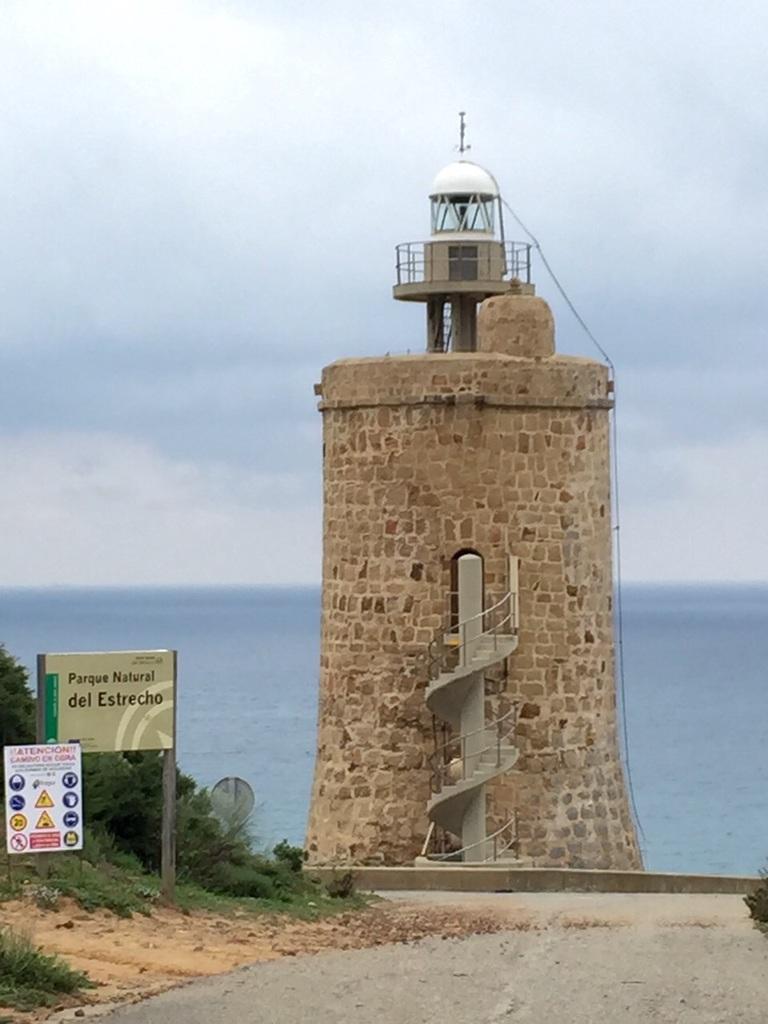Could you give a brief overview of what you see in this image? In this image I see a tower and I see the steps over here and I see the path and I see 2 boards over here on which there is something written and I see the plants. In the background I see the water and the sky which is a bit cloudy. 